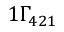<formula> <loc_0><loc_0><loc_500><loc_500>1 { \Gamma _ { 4 2 1 } }</formula> 